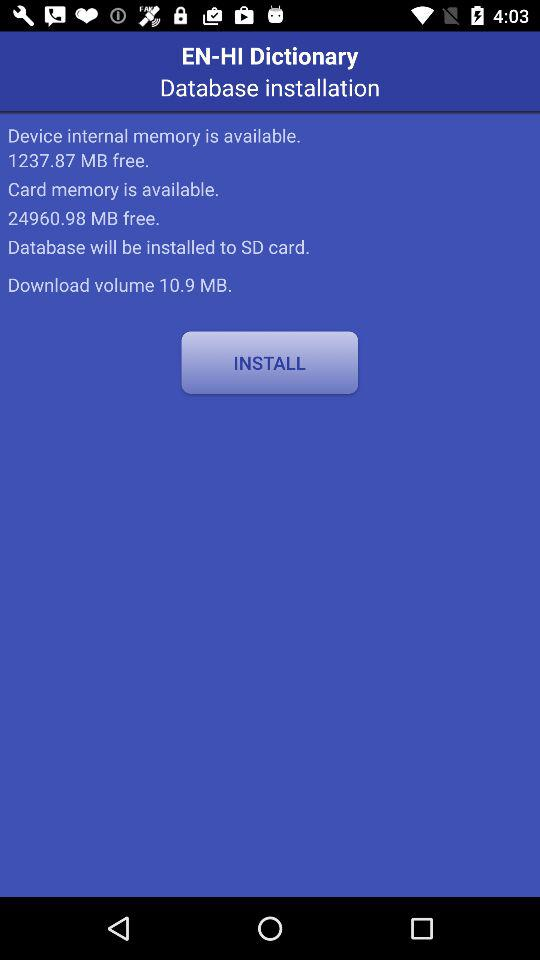Where will the databases be installed? The database will be installed on an SD card. 